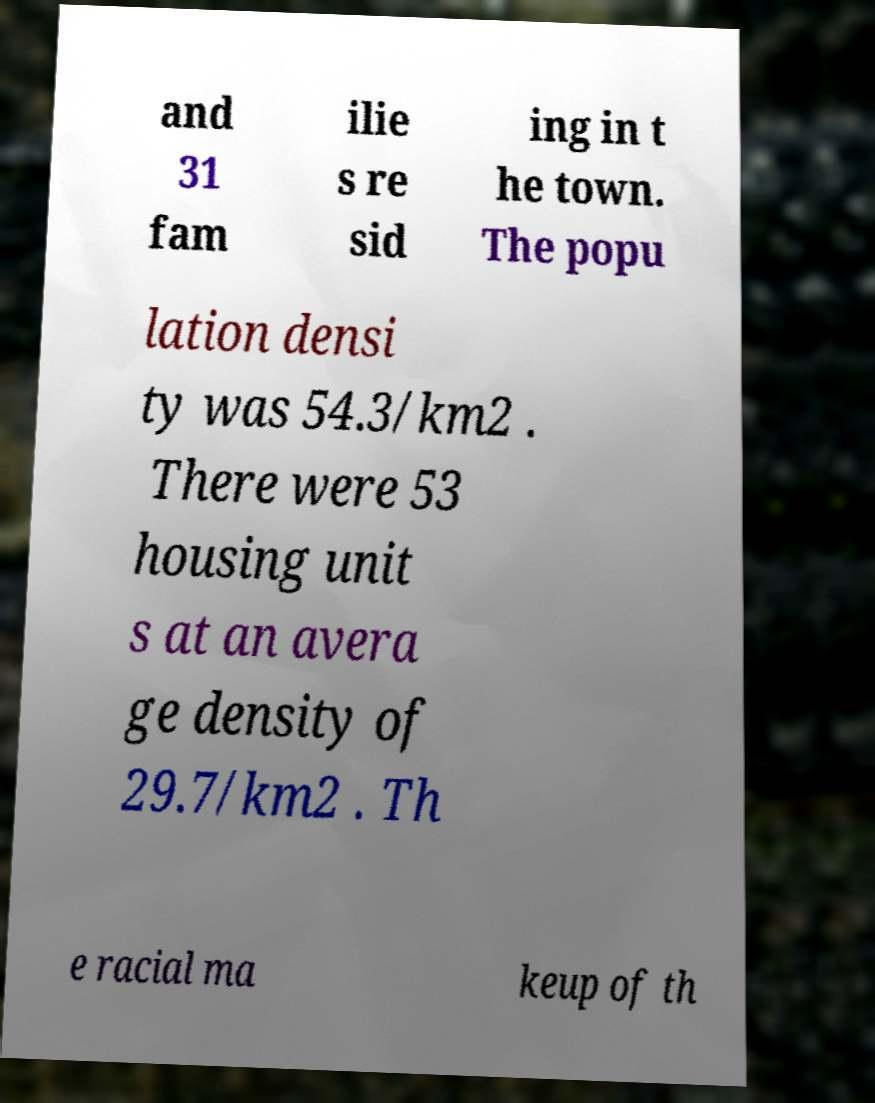Please identify and transcribe the text found in this image. and 31 fam ilie s re sid ing in t he town. The popu lation densi ty was 54.3/km2 . There were 53 housing unit s at an avera ge density of 29.7/km2 . Th e racial ma keup of th 